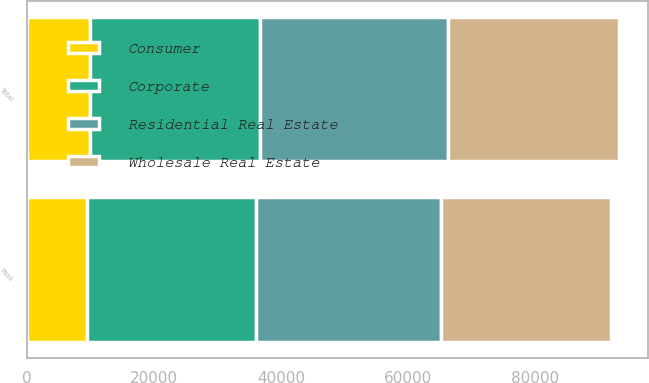Convert chart to OTSL. <chart><loc_0><loc_0><loc_500><loc_500><stacked_bar_chart><ecel><fcel>Pass<fcel>Total<nl><fcel>Residential Real Estate<fcel>29166<fcel>29754<nl><fcel>Wholesale Real Estate<fcel>26802<fcel>26808<nl><fcel>Corporate<fcel>26562<fcel>26635<nl><fcel>Consumer<fcel>9480<fcel>9980<nl></chart> 